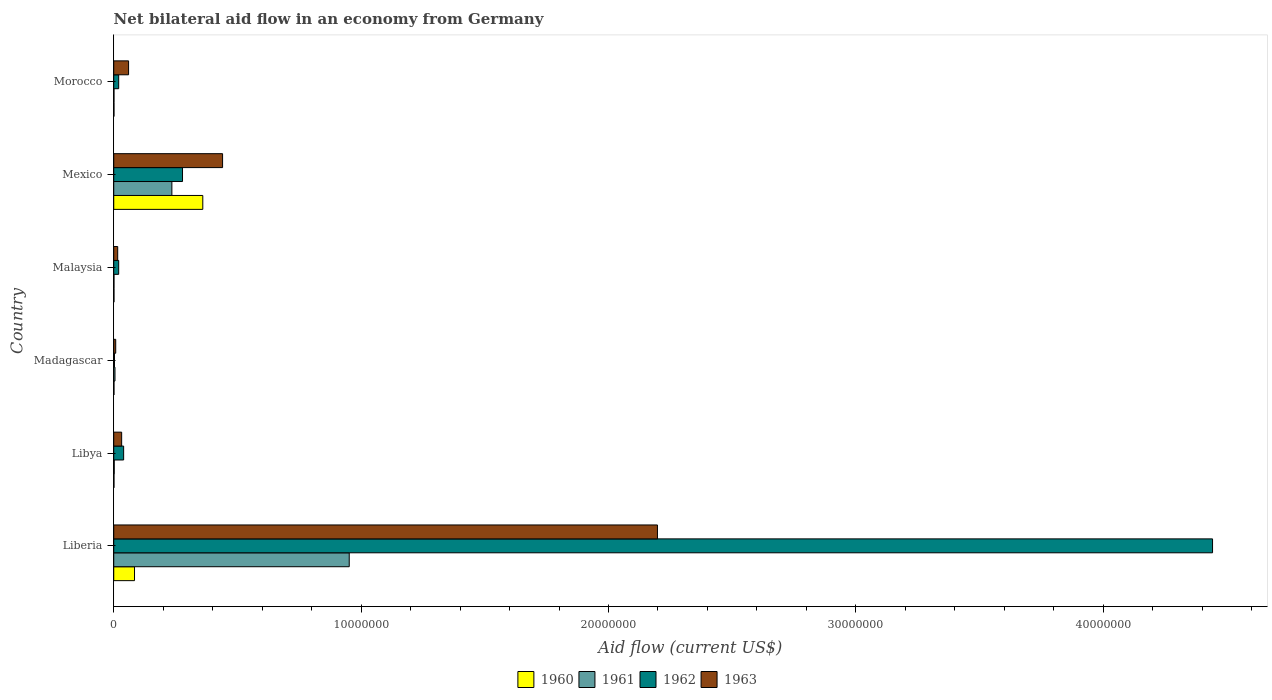How many groups of bars are there?
Your answer should be very brief. 6. How many bars are there on the 6th tick from the bottom?
Your answer should be compact. 4. What is the label of the 6th group of bars from the top?
Provide a short and direct response. Liberia. In how many cases, is the number of bars for a given country not equal to the number of legend labels?
Give a very brief answer. 0. Across all countries, what is the maximum net bilateral aid flow in 1961?
Make the answer very short. 9.52e+06. In which country was the net bilateral aid flow in 1963 maximum?
Your answer should be very brief. Liberia. In which country was the net bilateral aid flow in 1963 minimum?
Your answer should be very brief. Madagascar. What is the total net bilateral aid flow in 1962 in the graph?
Make the answer very short. 4.80e+07. What is the difference between the net bilateral aid flow in 1963 in Libya and that in Morocco?
Provide a succinct answer. -2.80e+05. What is the difference between the net bilateral aid flow in 1962 in Malaysia and the net bilateral aid flow in 1960 in Madagascar?
Provide a succinct answer. 1.90e+05. What is the average net bilateral aid flow in 1963 per country?
Provide a succinct answer. 4.59e+06. What is the difference between the net bilateral aid flow in 1960 and net bilateral aid flow in 1963 in Morocco?
Your answer should be compact. -5.90e+05. In how many countries, is the net bilateral aid flow in 1960 greater than 12000000 US$?
Your answer should be compact. 0. What is the ratio of the net bilateral aid flow in 1960 in Mexico to that in Morocco?
Give a very brief answer. 360. Is the net bilateral aid flow in 1963 in Libya less than that in Malaysia?
Provide a succinct answer. No. Is the difference between the net bilateral aid flow in 1960 in Libya and Madagascar greater than the difference between the net bilateral aid flow in 1963 in Libya and Madagascar?
Make the answer very short. No. What is the difference between the highest and the second highest net bilateral aid flow in 1962?
Keep it short and to the point. 4.16e+07. What is the difference between the highest and the lowest net bilateral aid flow in 1961?
Make the answer very short. 9.51e+06. Are all the bars in the graph horizontal?
Your answer should be very brief. Yes. How many countries are there in the graph?
Your answer should be very brief. 6. Are the values on the major ticks of X-axis written in scientific E-notation?
Give a very brief answer. No. Where does the legend appear in the graph?
Provide a short and direct response. Bottom center. How are the legend labels stacked?
Your response must be concise. Horizontal. What is the title of the graph?
Provide a succinct answer. Net bilateral aid flow in an economy from Germany. Does "1964" appear as one of the legend labels in the graph?
Ensure brevity in your answer.  No. What is the label or title of the Y-axis?
Offer a very short reply. Country. What is the Aid flow (current US$) of 1960 in Liberia?
Provide a short and direct response. 8.40e+05. What is the Aid flow (current US$) in 1961 in Liberia?
Provide a short and direct response. 9.52e+06. What is the Aid flow (current US$) of 1962 in Liberia?
Provide a succinct answer. 4.44e+07. What is the Aid flow (current US$) of 1963 in Liberia?
Give a very brief answer. 2.20e+07. What is the Aid flow (current US$) in 1960 in Libya?
Make the answer very short. 10000. What is the Aid flow (current US$) in 1961 in Libya?
Provide a succinct answer. 2.00e+04. What is the Aid flow (current US$) of 1960 in Madagascar?
Offer a terse response. 10000. What is the Aid flow (current US$) of 1963 in Madagascar?
Your answer should be compact. 8.00e+04. What is the Aid flow (current US$) in 1960 in Malaysia?
Ensure brevity in your answer.  10000. What is the Aid flow (current US$) of 1963 in Malaysia?
Provide a short and direct response. 1.60e+05. What is the Aid flow (current US$) of 1960 in Mexico?
Ensure brevity in your answer.  3.60e+06. What is the Aid flow (current US$) in 1961 in Mexico?
Provide a short and direct response. 2.35e+06. What is the Aid flow (current US$) in 1962 in Mexico?
Make the answer very short. 2.78e+06. What is the Aid flow (current US$) of 1963 in Mexico?
Keep it short and to the point. 4.40e+06. What is the Aid flow (current US$) in 1963 in Morocco?
Your answer should be very brief. 6.00e+05. Across all countries, what is the maximum Aid flow (current US$) of 1960?
Offer a very short reply. 3.60e+06. Across all countries, what is the maximum Aid flow (current US$) of 1961?
Keep it short and to the point. 9.52e+06. Across all countries, what is the maximum Aid flow (current US$) of 1962?
Offer a terse response. 4.44e+07. Across all countries, what is the maximum Aid flow (current US$) of 1963?
Make the answer very short. 2.20e+07. Across all countries, what is the minimum Aid flow (current US$) in 1960?
Ensure brevity in your answer.  10000. Across all countries, what is the minimum Aid flow (current US$) in 1962?
Provide a succinct answer. 3.00e+04. Across all countries, what is the minimum Aid flow (current US$) of 1963?
Offer a terse response. 8.00e+04. What is the total Aid flow (current US$) of 1960 in the graph?
Provide a short and direct response. 4.48e+06. What is the total Aid flow (current US$) in 1961 in the graph?
Your response must be concise. 1.20e+07. What is the total Aid flow (current US$) in 1962 in the graph?
Your answer should be very brief. 4.80e+07. What is the total Aid flow (current US$) in 1963 in the graph?
Give a very brief answer. 2.75e+07. What is the difference between the Aid flow (current US$) in 1960 in Liberia and that in Libya?
Give a very brief answer. 8.30e+05. What is the difference between the Aid flow (current US$) of 1961 in Liberia and that in Libya?
Give a very brief answer. 9.50e+06. What is the difference between the Aid flow (current US$) of 1962 in Liberia and that in Libya?
Offer a very short reply. 4.40e+07. What is the difference between the Aid flow (current US$) of 1963 in Liberia and that in Libya?
Provide a short and direct response. 2.17e+07. What is the difference between the Aid flow (current US$) in 1960 in Liberia and that in Madagascar?
Ensure brevity in your answer.  8.30e+05. What is the difference between the Aid flow (current US$) of 1961 in Liberia and that in Madagascar?
Give a very brief answer. 9.47e+06. What is the difference between the Aid flow (current US$) of 1962 in Liberia and that in Madagascar?
Make the answer very short. 4.44e+07. What is the difference between the Aid flow (current US$) in 1963 in Liberia and that in Madagascar?
Offer a very short reply. 2.19e+07. What is the difference between the Aid flow (current US$) of 1960 in Liberia and that in Malaysia?
Make the answer very short. 8.30e+05. What is the difference between the Aid flow (current US$) in 1961 in Liberia and that in Malaysia?
Your answer should be very brief. 9.51e+06. What is the difference between the Aid flow (current US$) in 1962 in Liberia and that in Malaysia?
Provide a short and direct response. 4.42e+07. What is the difference between the Aid flow (current US$) of 1963 in Liberia and that in Malaysia?
Give a very brief answer. 2.18e+07. What is the difference between the Aid flow (current US$) in 1960 in Liberia and that in Mexico?
Provide a succinct answer. -2.76e+06. What is the difference between the Aid flow (current US$) in 1961 in Liberia and that in Mexico?
Your answer should be very brief. 7.17e+06. What is the difference between the Aid flow (current US$) in 1962 in Liberia and that in Mexico?
Offer a very short reply. 4.16e+07. What is the difference between the Aid flow (current US$) in 1963 in Liberia and that in Mexico?
Ensure brevity in your answer.  1.76e+07. What is the difference between the Aid flow (current US$) in 1960 in Liberia and that in Morocco?
Offer a terse response. 8.30e+05. What is the difference between the Aid flow (current US$) in 1961 in Liberia and that in Morocco?
Provide a succinct answer. 9.51e+06. What is the difference between the Aid flow (current US$) in 1962 in Liberia and that in Morocco?
Provide a short and direct response. 4.42e+07. What is the difference between the Aid flow (current US$) in 1963 in Liberia and that in Morocco?
Your answer should be very brief. 2.14e+07. What is the difference between the Aid flow (current US$) in 1960 in Libya and that in Madagascar?
Your answer should be compact. 0. What is the difference between the Aid flow (current US$) in 1963 in Libya and that in Madagascar?
Your response must be concise. 2.40e+05. What is the difference between the Aid flow (current US$) of 1960 in Libya and that in Malaysia?
Make the answer very short. 0. What is the difference between the Aid flow (current US$) of 1961 in Libya and that in Malaysia?
Give a very brief answer. 10000. What is the difference between the Aid flow (current US$) of 1962 in Libya and that in Malaysia?
Offer a very short reply. 2.00e+05. What is the difference between the Aid flow (current US$) in 1960 in Libya and that in Mexico?
Your answer should be compact. -3.59e+06. What is the difference between the Aid flow (current US$) of 1961 in Libya and that in Mexico?
Make the answer very short. -2.33e+06. What is the difference between the Aid flow (current US$) in 1962 in Libya and that in Mexico?
Make the answer very short. -2.38e+06. What is the difference between the Aid flow (current US$) of 1963 in Libya and that in Mexico?
Offer a very short reply. -4.08e+06. What is the difference between the Aid flow (current US$) in 1960 in Libya and that in Morocco?
Offer a very short reply. 0. What is the difference between the Aid flow (current US$) of 1961 in Libya and that in Morocco?
Provide a short and direct response. 10000. What is the difference between the Aid flow (current US$) of 1963 in Libya and that in Morocco?
Ensure brevity in your answer.  -2.80e+05. What is the difference between the Aid flow (current US$) of 1960 in Madagascar and that in Malaysia?
Give a very brief answer. 0. What is the difference between the Aid flow (current US$) of 1962 in Madagascar and that in Malaysia?
Make the answer very short. -1.70e+05. What is the difference between the Aid flow (current US$) of 1960 in Madagascar and that in Mexico?
Keep it short and to the point. -3.59e+06. What is the difference between the Aid flow (current US$) in 1961 in Madagascar and that in Mexico?
Ensure brevity in your answer.  -2.30e+06. What is the difference between the Aid flow (current US$) of 1962 in Madagascar and that in Mexico?
Your answer should be compact. -2.75e+06. What is the difference between the Aid flow (current US$) in 1963 in Madagascar and that in Mexico?
Provide a short and direct response. -4.32e+06. What is the difference between the Aid flow (current US$) in 1960 in Madagascar and that in Morocco?
Your answer should be very brief. 0. What is the difference between the Aid flow (current US$) in 1961 in Madagascar and that in Morocco?
Provide a short and direct response. 4.00e+04. What is the difference between the Aid flow (current US$) in 1963 in Madagascar and that in Morocco?
Offer a very short reply. -5.20e+05. What is the difference between the Aid flow (current US$) of 1960 in Malaysia and that in Mexico?
Provide a short and direct response. -3.59e+06. What is the difference between the Aid flow (current US$) in 1961 in Malaysia and that in Mexico?
Your answer should be very brief. -2.34e+06. What is the difference between the Aid flow (current US$) in 1962 in Malaysia and that in Mexico?
Keep it short and to the point. -2.58e+06. What is the difference between the Aid flow (current US$) of 1963 in Malaysia and that in Mexico?
Your response must be concise. -4.24e+06. What is the difference between the Aid flow (current US$) in 1960 in Malaysia and that in Morocco?
Make the answer very short. 0. What is the difference between the Aid flow (current US$) of 1961 in Malaysia and that in Morocco?
Offer a very short reply. 0. What is the difference between the Aid flow (current US$) in 1963 in Malaysia and that in Morocco?
Your response must be concise. -4.40e+05. What is the difference between the Aid flow (current US$) in 1960 in Mexico and that in Morocco?
Offer a terse response. 3.59e+06. What is the difference between the Aid flow (current US$) of 1961 in Mexico and that in Morocco?
Ensure brevity in your answer.  2.34e+06. What is the difference between the Aid flow (current US$) of 1962 in Mexico and that in Morocco?
Your answer should be compact. 2.58e+06. What is the difference between the Aid flow (current US$) in 1963 in Mexico and that in Morocco?
Your answer should be compact. 3.80e+06. What is the difference between the Aid flow (current US$) of 1960 in Liberia and the Aid flow (current US$) of 1961 in Libya?
Keep it short and to the point. 8.20e+05. What is the difference between the Aid flow (current US$) in 1960 in Liberia and the Aid flow (current US$) in 1962 in Libya?
Make the answer very short. 4.40e+05. What is the difference between the Aid flow (current US$) of 1960 in Liberia and the Aid flow (current US$) of 1963 in Libya?
Your answer should be very brief. 5.20e+05. What is the difference between the Aid flow (current US$) of 1961 in Liberia and the Aid flow (current US$) of 1962 in Libya?
Keep it short and to the point. 9.12e+06. What is the difference between the Aid flow (current US$) of 1961 in Liberia and the Aid flow (current US$) of 1963 in Libya?
Give a very brief answer. 9.20e+06. What is the difference between the Aid flow (current US$) of 1962 in Liberia and the Aid flow (current US$) of 1963 in Libya?
Give a very brief answer. 4.41e+07. What is the difference between the Aid flow (current US$) of 1960 in Liberia and the Aid flow (current US$) of 1961 in Madagascar?
Your answer should be very brief. 7.90e+05. What is the difference between the Aid flow (current US$) in 1960 in Liberia and the Aid flow (current US$) in 1962 in Madagascar?
Your response must be concise. 8.10e+05. What is the difference between the Aid flow (current US$) in 1960 in Liberia and the Aid flow (current US$) in 1963 in Madagascar?
Keep it short and to the point. 7.60e+05. What is the difference between the Aid flow (current US$) of 1961 in Liberia and the Aid flow (current US$) of 1962 in Madagascar?
Offer a very short reply. 9.49e+06. What is the difference between the Aid flow (current US$) in 1961 in Liberia and the Aid flow (current US$) in 1963 in Madagascar?
Your answer should be very brief. 9.44e+06. What is the difference between the Aid flow (current US$) in 1962 in Liberia and the Aid flow (current US$) in 1963 in Madagascar?
Offer a very short reply. 4.43e+07. What is the difference between the Aid flow (current US$) of 1960 in Liberia and the Aid flow (current US$) of 1961 in Malaysia?
Provide a succinct answer. 8.30e+05. What is the difference between the Aid flow (current US$) in 1960 in Liberia and the Aid flow (current US$) in 1962 in Malaysia?
Offer a very short reply. 6.40e+05. What is the difference between the Aid flow (current US$) of 1960 in Liberia and the Aid flow (current US$) of 1963 in Malaysia?
Your answer should be very brief. 6.80e+05. What is the difference between the Aid flow (current US$) of 1961 in Liberia and the Aid flow (current US$) of 1962 in Malaysia?
Make the answer very short. 9.32e+06. What is the difference between the Aid flow (current US$) of 1961 in Liberia and the Aid flow (current US$) of 1963 in Malaysia?
Offer a terse response. 9.36e+06. What is the difference between the Aid flow (current US$) in 1962 in Liberia and the Aid flow (current US$) in 1963 in Malaysia?
Keep it short and to the point. 4.43e+07. What is the difference between the Aid flow (current US$) in 1960 in Liberia and the Aid flow (current US$) in 1961 in Mexico?
Ensure brevity in your answer.  -1.51e+06. What is the difference between the Aid flow (current US$) of 1960 in Liberia and the Aid flow (current US$) of 1962 in Mexico?
Make the answer very short. -1.94e+06. What is the difference between the Aid flow (current US$) of 1960 in Liberia and the Aid flow (current US$) of 1963 in Mexico?
Offer a terse response. -3.56e+06. What is the difference between the Aid flow (current US$) in 1961 in Liberia and the Aid flow (current US$) in 1962 in Mexico?
Your response must be concise. 6.74e+06. What is the difference between the Aid flow (current US$) of 1961 in Liberia and the Aid flow (current US$) of 1963 in Mexico?
Your answer should be very brief. 5.12e+06. What is the difference between the Aid flow (current US$) of 1962 in Liberia and the Aid flow (current US$) of 1963 in Mexico?
Ensure brevity in your answer.  4.00e+07. What is the difference between the Aid flow (current US$) of 1960 in Liberia and the Aid flow (current US$) of 1961 in Morocco?
Give a very brief answer. 8.30e+05. What is the difference between the Aid flow (current US$) in 1960 in Liberia and the Aid flow (current US$) in 1962 in Morocco?
Offer a terse response. 6.40e+05. What is the difference between the Aid flow (current US$) in 1960 in Liberia and the Aid flow (current US$) in 1963 in Morocco?
Offer a very short reply. 2.40e+05. What is the difference between the Aid flow (current US$) in 1961 in Liberia and the Aid flow (current US$) in 1962 in Morocco?
Keep it short and to the point. 9.32e+06. What is the difference between the Aid flow (current US$) of 1961 in Liberia and the Aid flow (current US$) of 1963 in Morocco?
Provide a short and direct response. 8.92e+06. What is the difference between the Aid flow (current US$) of 1962 in Liberia and the Aid flow (current US$) of 1963 in Morocco?
Provide a short and direct response. 4.38e+07. What is the difference between the Aid flow (current US$) of 1960 in Libya and the Aid flow (current US$) of 1961 in Madagascar?
Ensure brevity in your answer.  -4.00e+04. What is the difference between the Aid flow (current US$) of 1960 in Libya and the Aid flow (current US$) of 1962 in Madagascar?
Your response must be concise. -2.00e+04. What is the difference between the Aid flow (current US$) in 1960 in Libya and the Aid flow (current US$) in 1963 in Madagascar?
Keep it short and to the point. -7.00e+04. What is the difference between the Aid flow (current US$) of 1962 in Libya and the Aid flow (current US$) of 1963 in Madagascar?
Make the answer very short. 3.20e+05. What is the difference between the Aid flow (current US$) of 1960 in Libya and the Aid flow (current US$) of 1961 in Malaysia?
Keep it short and to the point. 0. What is the difference between the Aid flow (current US$) of 1961 in Libya and the Aid flow (current US$) of 1962 in Malaysia?
Ensure brevity in your answer.  -1.80e+05. What is the difference between the Aid flow (current US$) of 1960 in Libya and the Aid flow (current US$) of 1961 in Mexico?
Offer a very short reply. -2.34e+06. What is the difference between the Aid flow (current US$) in 1960 in Libya and the Aid flow (current US$) in 1962 in Mexico?
Ensure brevity in your answer.  -2.77e+06. What is the difference between the Aid flow (current US$) of 1960 in Libya and the Aid flow (current US$) of 1963 in Mexico?
Give a very brief answer. -4.39e+06. What is the difference between the Aid flow (current US$) of 1961 in Libya and the Aid flow (current US$) of 1962 in Mexico?
Your answer should be compact. -2.76e+06. What is the difference between the Aid flow (current US$) of 1961 in Libya and the Aid flow (current US$) of 1963 in Mexico?
Your answer should be very brief. -4.38e+06. What is the difference between the Aid flow (current US$) in 1960 in Libya and the Aid flow (current US$) in 1963 in Morocco?
Provide a short and direct response. -5.90e+05. What is the difference between the Aid flow (current US$) of 1961 in Libya and the Aid flow (current US$) of 1962 in Morocco?
Provide a succinct answer. -1.80e+05. What is the difference between the Aid flow (current US$) of 1961 in Libya and the Aid flow (current US$) of 1963 in Morocco?
Offer a terse response. -5.80e+05. What is the difference between the Aid flow (current US$) of 1962 in Libya and the Aid flow (current US$) of 1963 in Morocco?
Keep it short and to the point. -2.00e+05. What is the difference between the Aid flow (current US$) in 1960 in Madagascar and the Aid flow (current US$) in 1961 in Malaysia?
Offer a very short reply. 0. What is the difference between the Aid flow (current US$) of 1961 in Madagascar and the Aid flow (current US$) of 1963 in Malaysia?
Ensure brevity in your answer.  -1.10e+05. What is the difference between the Aid flow (current US$) of 1962 in Madagascar and the Aid flow (current US$) of 1963 in Malaysia?
Give a very brief answer. -1.30e+05. What is the difference between the Aid flow (current US$) in 1960 in Madagascar and the Aid flow (current US$) in 1961 in Mexico?
Offer a terse response. -2.34e+06. What is the difference between the Aid flow (current US$) in 1960 in Madagascar and the Aid flow (current US$) in 1962 in Mexico?
Offer a terse response. -2.77e+06. What is the difference between the Aid flow (current US$) in 1960 in Madagascar and the Aid flow (current US$) in 1963 in Mexico?
Provide a succinct answer. -4.39e+06. What is the difference between the Aid flow (current US$) of 1961 in Madagascar and the Aid flow (current US$) of 1962 in Mexico?
Ensure brevity in your answer.  -2.73e+06. What is the difference between the Aid flow (current US$) of 1961 in Madagascar and the Aid flow (current US$) of 1963 in Mexico?
Provide a short and direct response. -4.35e+06. What is the difference between the Aid flow (current US$) in 1962 in Madagascar and the Aid flow (current US$) in 1963 in Mexico?
Offer a terse response. -4.37e+06. What is the difference between the Aid flow (current US$) of 1960 in Madagascar and the Aid flow (current US$) of 1963 in Morocco?
Your answer should be compact. -5.90e+05. What is the difference between the Aid flow (current US$) in 1961 in Madagascar and the Aid flow (current US$) in 1962 in Morocco?
Offer a terse response. -1.50e+05. What is the difference between the Aid flow (current US$) of 1961 in Madagascar and the Aid flow (current US$) of 1963 in Morocco?
Give a very brief answer. -5.50e+05. What is the difference between the Aid flow (current US$) in 1962 in Madagascar and the Aid flow (current US$) in 1963 in Morocco?
Provide a short and direct response. -5.70e+05. What is the difference between the Aid flow (current US$) of 1960 in Malaysia and the Aid flow (current US$) of 1961 in Mexico?
Ensure brevity in your answer.  -2.34e+06. What is the difference between the Aid flow (current US$) of 1960 in Malaysia and the Aid flow (current US$) of 1962 in Mexico?
Provide a short and direct response. -2.77e+06. What is the difference between the Aid flow (current US$) of 1960 in Malaysia and the Aid flow (current US$) of 1963 in Mexico?
Your answer should be very brief. -4.39e+06. What is the difference between the Aid flow (current US$) of 1961 in Malaysia and the Aid flow (current US$) of 1962 in Mexico?
Offer a terse response. -2.77e+06. What is the difference between the Aid flow (current US$) of 1961 in Malaysia and the Aid flow (current US$) of 1963 in Mexico?
Provide a short and direct response. -4.39e+06. What is the difference between the Aid flow (current US$) of 1962 in Malaysia and the Aid flow (current US$) of 1963 in Mexico?
Provide a succinct answer. -4.20e+06. What is the difference between the Aid flow (current US$) in 1960 in Malaysia and the Aid flow (current US$) in 1962 in Morocco?
Make the answer very short. -1.90e+05. What is the difference between the Aid flow (current US$) in 1960 in Malaysia and the Aid flow (current US$) in 1963 in Morocco?
Provide a succinct answer. -5.90e+05. What is the difference between the Aid flow (current US$) of 1961 in Malaysia and the Aid flow (current US$) of 1962 in Morocco?
Your response must be concise. -1.90e+05. What is the difference between the Aid flow (current US$) of 1961 in Malaysia and the Aid flow (current US$) of 1963 in Morocco?
Make the answer very short. -5.90e+05. What is the difference between the Aid flow (current US$) of 1962 in Malaysia and the Aid flow (current US$) of 1963 in Morocco?
Provide a succinct answer. -4.00e+05. What is the difference between the Aid flow (current US$) of 1960 in Mexico and the Aid flow (current US$) of 1961 in Morocco?
Give a very brief answer. 3.59e+06. What is the difference between the Aid flow (current US$) of 1960 in Mexico and the Aid flow (current US$) of 1962 in Morocco?
Ensure brevity in your answer.  3.40e+06. What is the difference between the Aid flow (current US$) in 1961 in Mexico and the Aid flow (current US$) in 1962 in Morocco?
Offer a very short reply. 2.15e+06. What is the difference between the Aid flow (current US$) of 1961 in Mexico and the Aid flow (current US$) of 1963 in Morocco?
Your response must be concise. 1.75e+06. What is the difference between the Aid flow (current US$) of 1962 in Mexico and the Aid flow (current US$) of 1963 in Morocco?
Offer a very short reply. 2.18e+06. What is the average Aid flow (current US$) of 1960 per country?
Offer a terse response. 7.47e+05. What is the average Aid flow (current US$) in 1961 per country?
Keep it short and to the point. 1.99e+06. What is the average Aid flow (current US$) of 1962 per country?
Make the answer very short. 8.00e+06. What is the average Aid flow (current US$) of 1963 per country?
Your answer should be compact. 4.59e+06. What is the difference between the Aid flow (current US$) in 1960 and Aid flow (current US$) in 1961 in Liberia?
Ensure brevity in your answer.  -8.68e+06. What is the difference between the Aid flow (current US$) in 1960 and Aid flow (current US$) in 1962 in Liberia?
Your answer should be compact. -4.36e+07. What is the difference between the Aid flow (current US$) in 1960 and Aid flow (current US$) in 1963 in Liberia?
Ensure brevity in your answer.  -2.11e+07. What is the difference between the Aid flow (current US$) in 1961 and Aid flow (current US$) in 1962 in Liberia?
Make the answer very short. -3.49e+07. What is the difference between the Aid flow (current US$) in 1961 and Aid flow (current US$) in 1963 in Liberia?
Ensure brevity in your answer.  -1.25e+07. What is the difference between the Aid flow (current US$) in 1962 and Aid flow (current US$) in 1963 in Liberia?
Offer a very short reply. 2.24e+07. What is the difference between the Aid flow (current US$) in 1960 and Aid flow (current US$) in 1962 in Libya?
Provide a succinct answer. -3.90e+05. What is the difference between the Aid flow (current US$) of 1960 and Aid flow (current US$) of 1963 in Libya?
Offer a terse response. -3.10e+05. What is the difference between the Aid flow (current US$) in 1961 and Aid flow (current US$) in 1962 in Libya?
Keep it short and to the point. -3.80e+05. What is the difference between the Aid flow (current US$) in 1960 and Aid flow (current US$) in 1963 in Madagascar?
Your response must be concise. -7.00e+04. What is the difference between the Aid flow (current US$) in 1961 and Aid flow (current US$) in 1963 in Madagascar?
Ensure brevity in your answer.  -3.00e+04. What is the difference between the Aid flow (current US$) in 1962 and Aid flow (current US$) in 1963 in Madagascar?
Offer a very short reply. -5.00e+04. What is the difference between the Aid flow (current US$) of 1960 and Aid flow (current US$) of 1963 in Malaysia?
Offer a very short reply. -1.50e+05. What is the difference between the Aid flow (current US$) of 1960 and Aid flow (current US$) of 1961 in Mexico?
Keep it short and to the point. 1.25e+06. What is the difference between the Aid flow (current US$) in 1960 and Aid flow (current US$) in 1962 in Mexico?
Your response must be concise. 8.20e+05. What is the difference between the Aid flow (current US$) of 1960 and Aid flow (current US$) of 1963 in Mexico?
Offer a very short reply. -8.00e+05. What is the difference between the Aid flow (current US$) of 1961 and Aid flow (current US$) of 1962 in Mexico?
Ensure brevity in your answer.  -4.30e+05. What is the difference between the Aid flow (current US$) in 1961 and Aid flow (current US$) in 1963 in Mexico?
Your answer should be very brief. -2.05e+06. What is the difference between the Aid flow (current US$) in 1962 and Aid flow (current US$) in 1963 in Mexico?
Ensure brevity in your answer.  -1.62e+06. What is the difference between the Aid flow (current US$) of 1960 and Aid flow (current US$) of 1962 in Morocco?
Keep it short and to the point. -1.90e+05. What is the difference between the Aid flow (current US$) of 1960 and Aid flow (current US$) of 1963 in Morocco?
Your response must be concise. -5.90e+05. What is the difference between the Aid flow (current US$) of 1961 and Aid flow (current US$) of 1963 in Morocco?
Your answer should be very brief. -5.90e+05. What is the difference between the Aid flow (current US$) in 1962 and Aid flow (current US$) in 1963 in Morocco?
Your response must be concise. -4.00e+05. What is the ratio of the Aid flow (current US$) of 1960 in Liberia to that in Libya?
Offer a very short reply. 84. What is the ratio of the Aid flow (current US$) in 1961 in Liberia to that in Libya?
Your response must be concise. 476. What is the ratio of the Aid flow (current US$) of 1962 in Liberia to that in Libya?
Your response must be concise. 111.05. What is the ratio of the Aid flow (current US$) in 1963 in Liberia to that in Libya?
Offer a terse response. 68.69. What is the ratio of the Aid flow (current US$) of 1960 in Liberia to that in Madagascar?
Offer a very short reply. 84. What is the ratio of the Aid flow (current US$) of 1961 in Liberia to that in Madagascar?
Ensure brevity in your answer.  190.4. What is the ratio of the Aid flow (current US$) in 1962 in Liberia to that in Madagascar?
Keep it short and to the point. 1480.67. What is the ratio of the Aid flow (current US$) of 1963 in Liberia to that in Madagascar?
Provide a short and direct response. 274.75. What is the ratio of the Aid flow (current US$) of 1961 in Liberia to that in Malaysia?
Your answer should be compact. 952. What is the ratio of the Aid flow (current US$) of 1962 in Liberia to that in Malaysia?
Keep it short and to the point. 222.1. What is the ratio of the Aid flow (current US$) in 1963 in Liberia to that in Malaysia?
Give a very brief answer. 137.38. What is the ratio of the Aid flow (current US$) in 1960 in Liberia to that in Mexico?
Offer a very short reply. 0.23. What is the ratio of the Aid flow (current US$) of 1961 in Liberia to that in Mexico?
Your response must be concise. 4.05. What is the ratio of the Aid flow (current US$) of 1962 in Liberia to that in Mexico?
Offer a terse response. 15.98. What is the ratio of the Aid flow (current US$) of 1963 in Liberia to that in Mexico?
Keep it short and to the point. 5. What is the ratio of the Aid flow (current US$) of 1960 in Liberia to that in Morocco?
Offer a very short reply. 84. What is the ratio of the Aid flow (current US$) of 1961 in Liberia to that in Morocco?
Ensure brevity in your answer.  952. What is the ratio of the Aid flow (current US$) in 1962 in Liberia to that in Morocco?
Offer a terse response. 222.1. What is the ratio of the Aid flow (current US$) of 1963 in Liberia to that in Morocco?
Offer a very short reply. 36.63. What is the ratio of the Aid flow (current US$) of 1960 in Libya to that in Madagascar?
Keep it short and to the point. 1. What is the ratio of the Aid flow (current US$) in 1961 in Libya to that in Madagascar?
Provide a succinct answer. 0.4. What is the ratio of the Aid flow (current US$) of 1962 in Libya to that in Madagascar?
Provide a succinct answer. 13.33. What is the ratio of the Aid flow (current US$) in 1963 in Libya to that in Madagascar?
Give a very brief answer. 4. What is the ratio of the Aid flow (current US$) in 1960 in Libya to that in Malaysia?
Ensure brevity in your answer.  1. What is the ratio of the Aid flow (current US$) of 1962 in Libya to that in Malaysia?
Your answer should be very brief. 2. What is the ratio of the Aid flow (current US$) of 1960 in Libya to that in Mexico?
Provide a short and direct response. 0. What is the ratio of the Aid flow (current US$) in 1961 in Libya to that in Mexico?
Your answer should be compact. 0.01. What is the ratio of the Aid flow (current US$) in 1962 in Libya to that in Mexico?
Provide a succinct answer. 0.14. What is the ratio of the Aid flow (current US$) in 1963 in Libya to that in Mexico?
Provide a short and direct response. 0.07. What is the ratio of the Aid flow (current US$) of 1960 in Libya to that in Morocco?
Make the answer very short. 1. What is the ratio of the Aid flow (current US$) in 1963 in Libya to that in Morocco?
Your answer should be very brief. 0.53. What is the ratio of the Aid flow (current US$) of 1960 in Madagascar to that in Malaysia?
Provide a short and direct response. 1. What is the ratio of the Aid flow (current US$) in 1961 in Madagascar to that in Malaysia?
Keep it short and to the point. 5. What is the ratio of the Aid flow (current US$) of 1962 in Madagascar to that in Malaysia?
Your response must be concise. 0.15. What is the ratio of the Aid flow (current US$) of 1963 in Madagascar to that in Malaysia?
Your response must be concise. 0.5. What is the ratio of the Aid flow (current US$) of 1960 in Madagascar to that in Mexico?
Your response must be concise. 0. What is the ratio of the Aid flow (current US$) of 1961 in Madagascar to that in Mexico?
Ensure brevity in your answer.  0.02. What is the ratio of the Aid flow (current US$) in 1962 in Madagascar to that in Mexico?
Keep it short and to the point. 0.01. What is the ratio of the Aid flow (current US$) in 1963 in Madagascar to that in Mexico?
Provide a succinct answer. 0.02. What is the ratio of the Aid flow (current US$) in 1961 in Madagascar to that in Morocco?
Give a very brief answer. 5. What is the ratio of the Aid flow (current US$) of 1963 in Madagascar to that in Morocco?
Your answer should be compact. 0.13. What is the ratio of the Aid flow (current US$) in 1960 in Malaysia to that in Mexico?
Provide a short and direct response. 0. What is the ratio of the Aid flow (current US$) in 1961 in Malaysia to that in Mexico?
Ensure brevity in your answer.  0. What is the ratio of the Aid flow (current US$) of 1962 in Malaysia to that in Mexico?
Your answer should be very brief. 0.07. What is the ratio of the Aid flow (current US$) of 1963 in Malaysia to that in Mexico?
Provide a short and direct response. 0.04. What is the ratio of the Aid flow (current US$) in 1963 in Malaysia to that in Morocco?
Provide a short and direct response. 0.27. What is the ratio of the Aid flow (current US$) in 1960 in Mexico to that in Morocco?
Offer a very short reply. 360. What is the ratio of the Aid flow (current US$) of 1961 in Mexico to that in Morocco?
Provide a short and direct response. 235. What is the ratio of the Aid flow (current US$) of 1962 in Mexico to that in Morocco?
Offer a terse response. 13.9. What is the ratio of the Aid flow (current US$) of 1963 in Mexico to that in Morocco?
Keep it short and to the point. 7.33. What is the difference between the highest and the second highest Aid flow (current US$) in 1960?
Your answer should be compact. 2.76e+06. What is the difference between the highest and the second highest Aid flow (current US$) of 1961?
Give a very brief answer. 7.17e+06. What is the difference between the highest and the second highest Aid flow (current US$) of 1962?
Your answer should be compact. 4.16e+07. What is the difference between the highest and the second highest Aid flow (current US$) of 1963?
Give a very brief answer. 1.76e+07. What is the difference between the highest and the lowest Aid flow (current US$) in 1960?
Keep it short and to the point. 3.59e+06. What is the difference between the highest and the lowest Aid flow (current US$) in 1961?
Ensure brevity in your answer.  9.51e+06. What is the difference between the highest and the lowest Aid flow (current US$) in 1962?
Ensure brevity in your answer.  4.44e+07. What is the difference between the highest and the lowest Aid flow (current US$) of 1963?
Make the answer very short. 2.19e+07. 